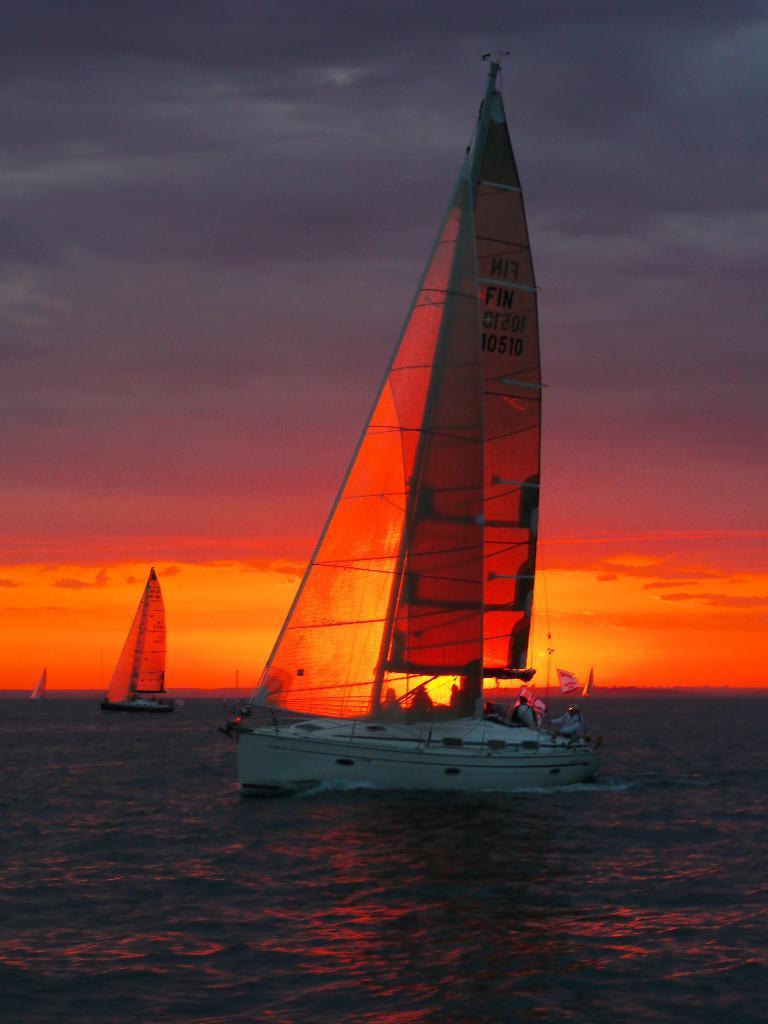Could you give a brief overview of what you see in this image? In the image we can see there is a sailboat in which there are people sitting and behind there are other sailboats. 